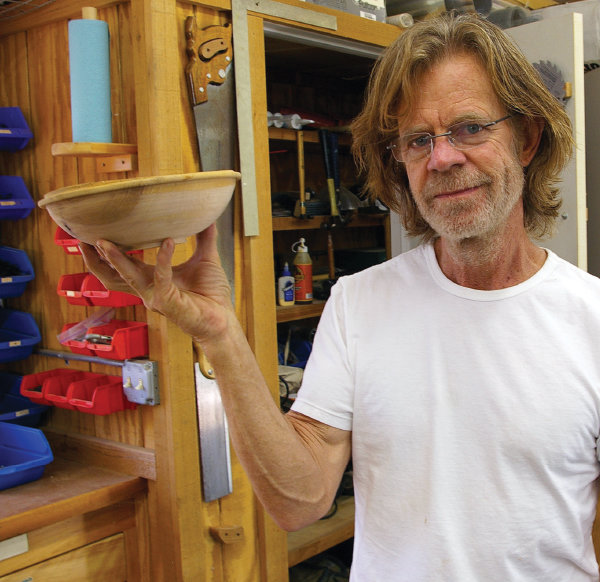What does the attire of the person in the image suggest? The person's attire—a plain white t-shirt and practical eyewear—suggests a casual and comfortable approach to their work in the shop. It indicates that the individual is likely engaging in the woodworking activity for personal enjoyment or as a hobby, where practicality is preferred over formal or protective clothing. 